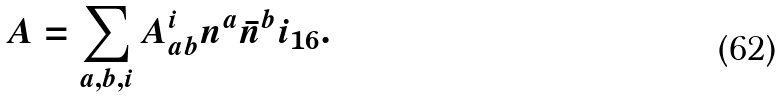<formula> <loc_0><loc_0><loc_500><loc_500>A = \sum _ { a , b , i } A _ { a b } ^ { i } n ^ { a } \bar { n } ^ { b } i _ { 1 6 } .</formula> 